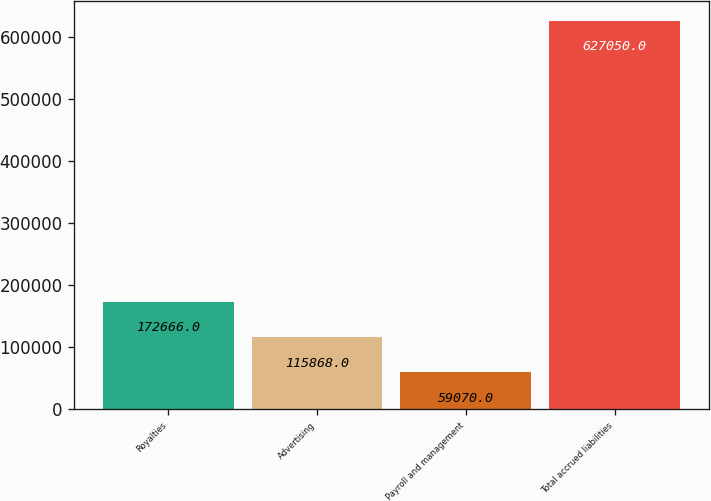<chart> <loc_0><loc_0><loc_500><loc_500><bar_chart><fcel>Royalties<fcel>Advertising<fcel>Payroll and management<fcel>Total accrued liabilities<nl><fcel>172666<fcel>115868<fcel>59070<fcel>627050<nl></chart> 